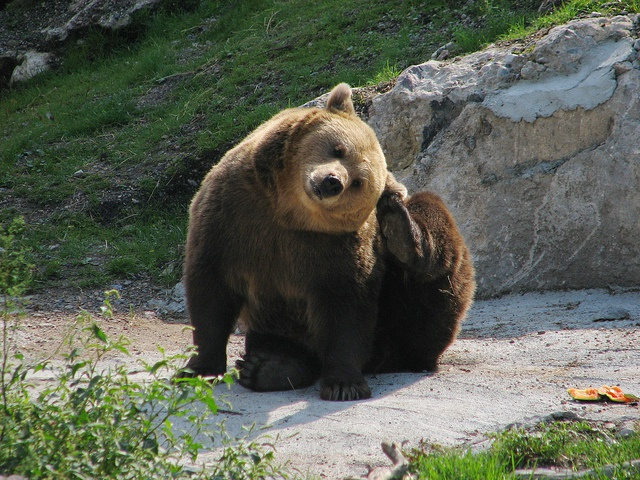Describe the objects in this image and their specific colors. I can see a bear in black, maroon, and gray tones in this image. 